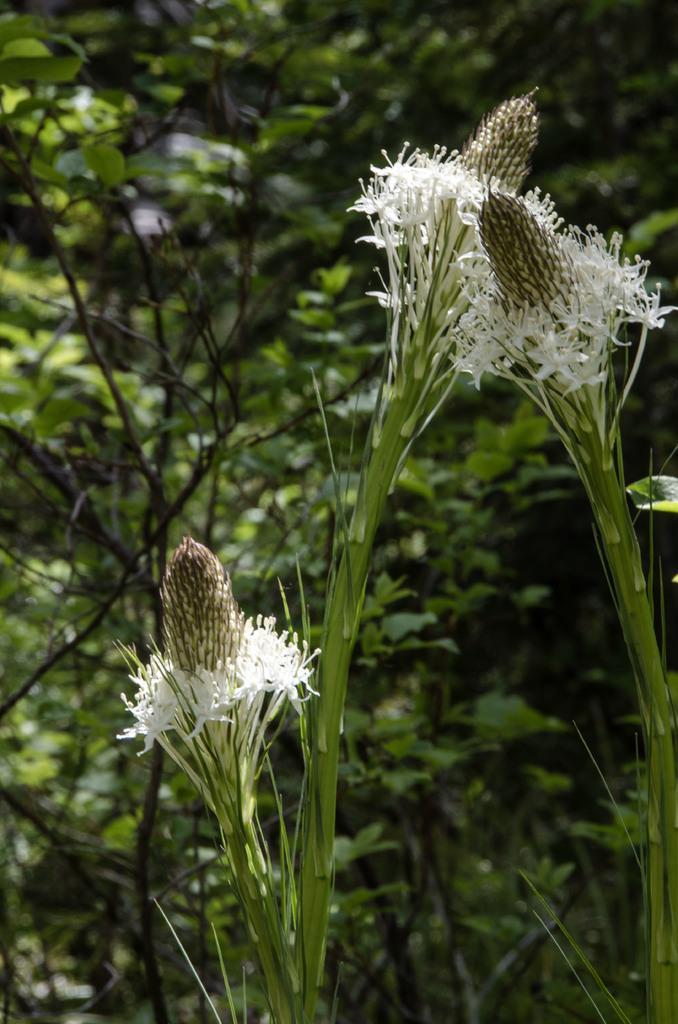In one or two sentences, can you explain what this image depicts? In this image we can see flowers. The background of the image is slightly blurred, where we can see plants. 